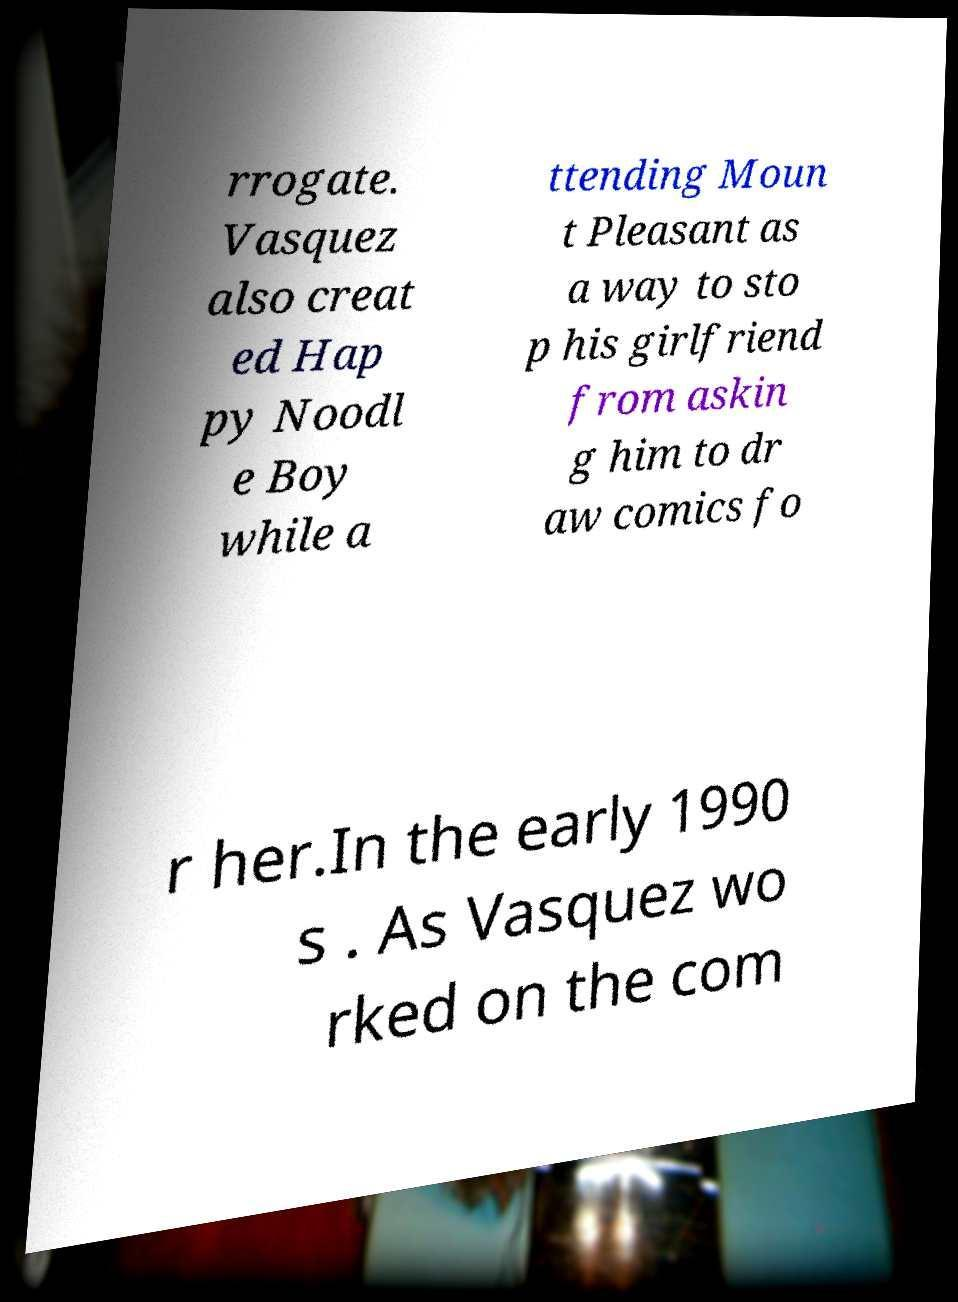What messages or text are displayed in this image? I need them in a readable, typed format. rrogate. Vasquez also creat ed Hap py Noodl e Boy while a ttending Moun t Pleasant as a way to sto p his girlfriend from askin g him to dr aw comics fo r her.In the early 1990 s . As Vasquez wo rked on the com 